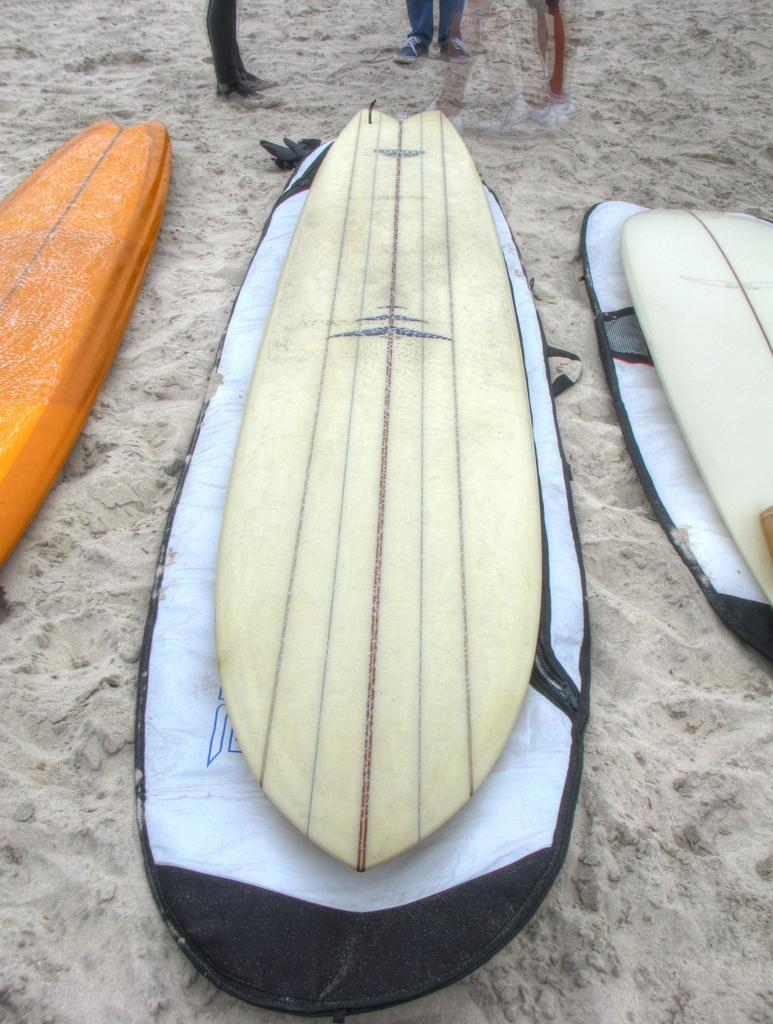How would you summarize this image in a sentence or two? In the center of the image there are three surfboards. At the bottom of the image there is sand. 